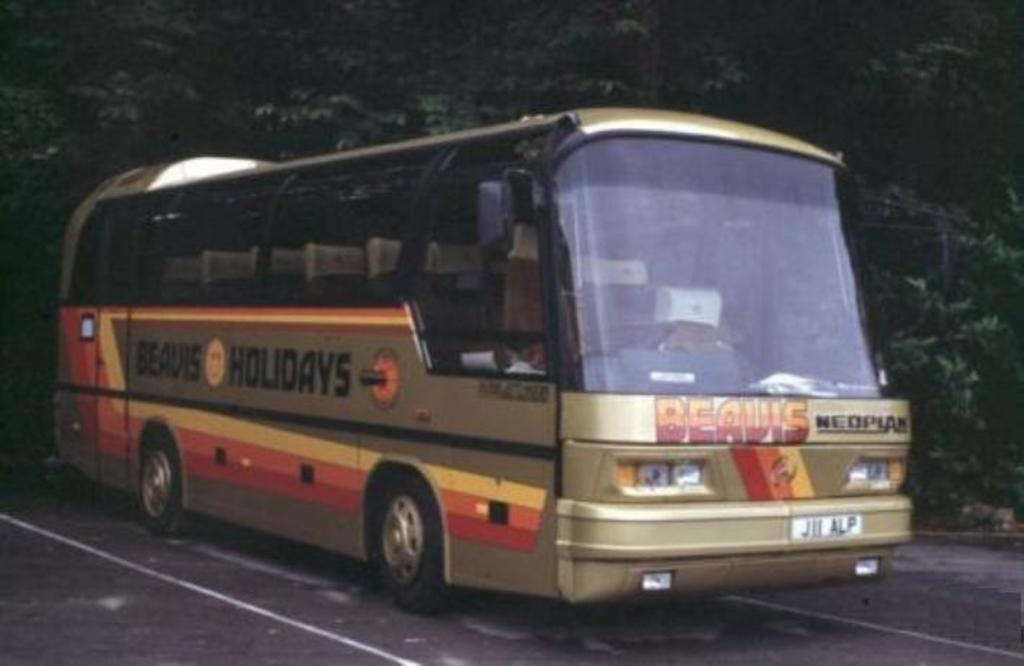What is the main subject of the image? There is a vehicle in the image. Where is the vehicle located? The vehicle is parked on the road. What can be seen in the background of the image? There is a group of trees in the background of the image. What type of card is being used by the passenger in the vehicle? There is no passenger mentioned in the image, and therefore no card usage can be observed. 